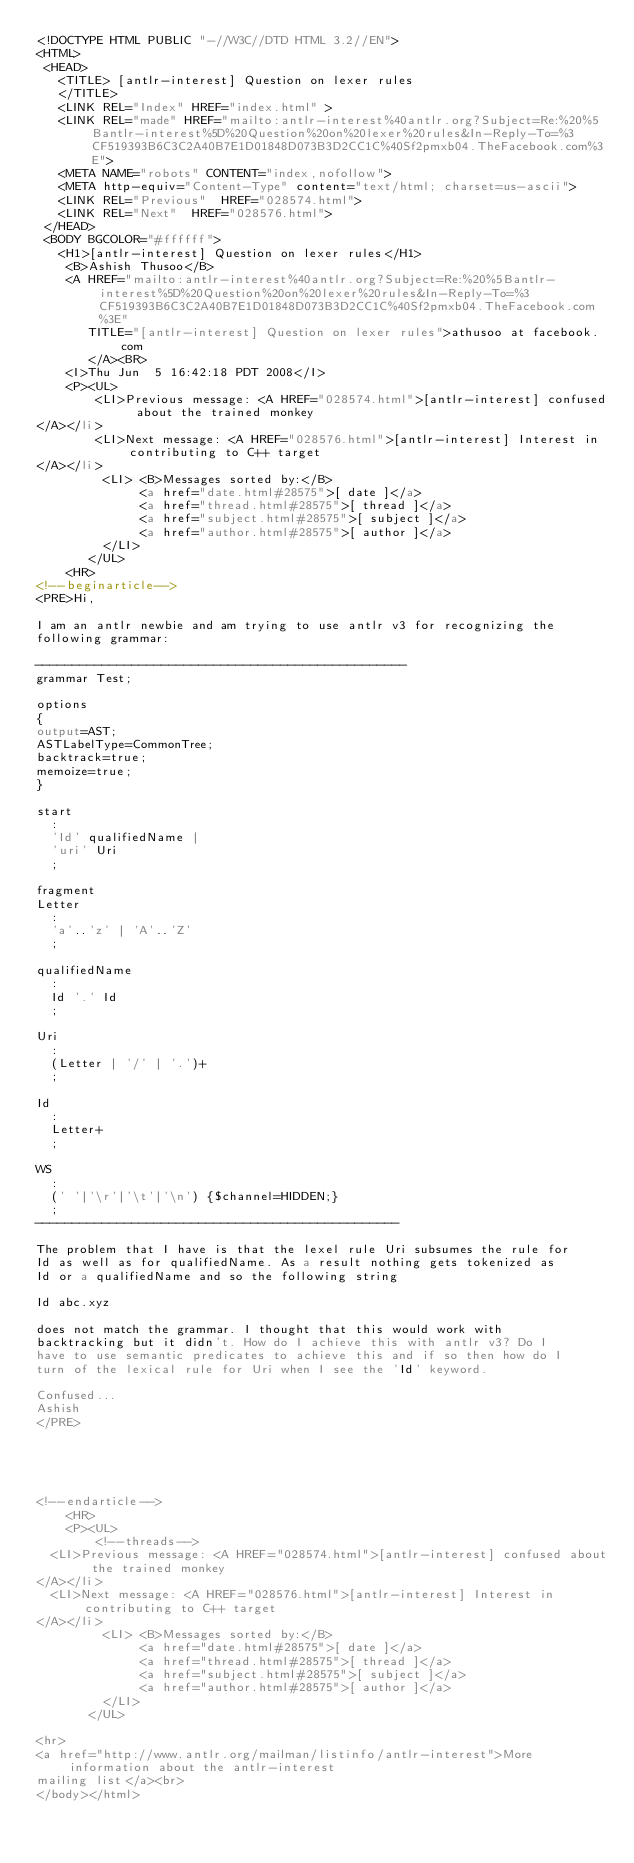<code> <loc_0><loc_0><loc_500><loc_500><_HTML_><!DOCTYPE HTML PUBLIC "-//W3C//DTD HTML 3.2//EN">
<HTML>
 <HEAD>
   <TITLE> [antlr-interest] Question on lexer rules
   </TITLE>
   <LINK REL="Index" HREF="index.html" >
   <LINK REL="made" HREF="mailto:antlr-interest%40antlr.org?Subject=Re:%20%5Bantlr-interest%5D%20Question%20on%20lexer%20rules&In-Reply-To=%3CF519393B6C3C2A40B7E1D01848D073B3D2CC1C%40Sf2pmxb04.TheFacebook.com%3E">
   <META NAME="robots" CONTENT="index,nofollow">
   <META http-equiv="Content-Type" content="text/html; charset=us-ascii">
   <LINK REL="Previous"  HREF="028574.html">
   <LINK REL="Next"  HREF="028576.html">
 </HEAD>
 <BODY BGCOLOR="#ffffff">
   <H1>[antlr-interest] Question on lexer rules</H1>
    <B>Ashish Thusoo</B> 
    <A HREF="mailto:antlr-interest%40antlr.org?Subject=Re:%20%5Bantlr-interest%5D%20Question%20on%20lexer%20rules&In-Reply-To=%3CF519393B6C3C2A40B7E1D01848D073B3D2CC1C%40Sf2pmxb04.TheFacebook.com%3E"
       TITLE="[antlr-interest] Question on lexer rules">athusoo at facebook.com
       </A><BR>
    <I>Thu Jun  5 16:42:18 PDT 2008</I>
    <P><UL>
        <LI>Previous message: <A HREF="028574.html">[antlr-interest] confused about the trained monkey
</A></li>
        <LI>Next message: <A HREF="028576.html">[antlr-interest] Interest in contributing to C++ target
</A></li>
         <LI> <B>Messages sorted by:</B> 
              <a href="date.html#28575">[ date ]</a>
              <a href="thread.html#28575">[ thread ]</a>
              <a href="subject.html#28575">[ subject ]</a>
              <a href="author.html#28575">[ author ]</a>
         </LI>
       </UL>
    <HR>  
<!--beginarticle-->
<PRE>Hi,

I am an antlr newbie and am trying to use antlr v3 for recognizing the
following grammar:

--------------------------------------------------
grammar Test;

options
{
output=AST;
ASTLabelType=CommonTree;
backtrack=true;
memoize=true;
}

start
  :
  'Id' qualifiedName |
  'uri' Uri
  ;
  
fragment
Letter
  :
  'a'..'z' | 'A'..'Z'
  ;

qualifiedName
  :
  Id '.' Id
  ;

Uri
  :
  (Letter | '/' | '.')+
  ;

Id
  :
  Letter+
  ;

WS
  :
  (' '|'\r'|'\t'|'\n') {$channel=HIDDEN;}
  ;
-------------------------------------------------

The problem that I have is that the lexel rule Uri subsumes the rule for
Id as well as for qualifiedName. As a result nothing gets tokenized as
Id or a qualifiedName and so the following string 

Id abc.xyz

does not match the grammar. I thought that this would work with
backtracking but it didn't. How do I achieve this with antlr v3? Do I
have to use semantic predicates to achieve this and if so then how do I
turn of the lexical rule for Uri when I see the 'Id' keyword.

Confused...
Ashish
</PRE>





<!--endarticle-->
    <HR>
    <P><UL>
        <!--threads-->
	<LI>Previous message: <A HREF="028574.html">[antlr-interest] confused about the trained monkey
</A></li>
	<LI>Next message: <A HREF="028576.html">[antlr-interest] Interest in contributing to C++ target
</A></li>
         <LI> <B>Messages sorted by:</B> 
              <a href="date.html#28575">[ date ]</a>
              <a href="thread.html#28575">[ thread ]</a>
              <a href="subject.html#28575">[ subject ]</a>
              <a href="author.html#28575">[ author ]</a>
         </LI>
       </UL>

<hr>
<a href="http://www.antlr.org/mailman/listinfo/antlr-interest">More information about the antlr-interest
mailing list</a><br>
</body></html>
</code> 